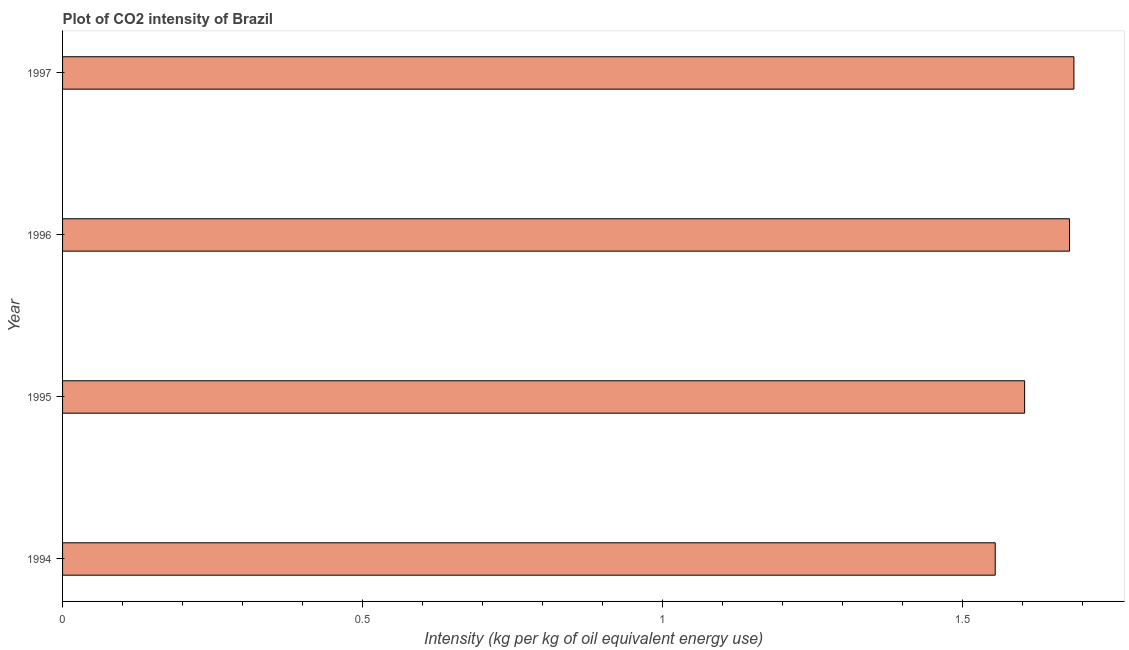Does the graph contain any zero values?
Ensure brevity in your answer.  No. What is the title of the graph?
Keep it short and to the point. Plot of CO2 intensity of Brazil. What is the label or title of the X-axis?
Your response must be concise. Intensity (kg per kg of oil equivalent energy use). What is the co2 intensity in 1996?
Your answer should be compact. 1.68. Across all years, what is the maximum co2 intensity?
Offer a very short reply. 1.69. Across all years, what is the minimum co2 intensity?
Your answer should be very brief. 1.55. In which year was the co2 intensity maximum?
Offer a very short reply. 1997. What is the sum of the co2 intensity?
Make the answer very short. 6.52. What is the difference between the co2 intensity in 1994 and 1997?
Ensure brevity in your answer.  -0.13. What is the average co2 intensity per year?
Keep it short and to the point. 1.63. What is the median co2 intensity?
Offer a very short reply. 1.64. Do a majority of the years between 1995 and 1997 (inclusive) have co2 intensity greater than 1.6 kg?
Keep it short and to the point. Yes. What is the ratio of the co2 intensity in 1994 to that in 1997?
Keep it short and to the point. 0.92. Is the difference between the co2 intensity in 1994 and 1997 greater than the difference between any two years?
Your response must be concise. Yes. What is the difference between the highest and the second highest co2 intensity?
Ensure brevity in your answer.  0.01. What is the difference between the highest and the lowest co2 intensity?
Your answer should be compact. 0.13. How many bars are there?
Provide a short and direct response. 4. Are all the bars in the graph horizontal?
Make the answer very short. Yes. How many years are there in the graph?
Make the answer very short. 4. What is the difference between two consecutive major ticks on the X-axis?
Provide a succinct answer. 0.5. What is the Intensity (kg per kg of oil equivalent energy use) of 1994?
Offer a terse response. 1.55. What is the Intensity (kg per kg of oil equivalent energy use) in 1995?
Give a very brief answer. 1.6. What is the Intensity (kg per kg of oil equivalent energy use) in 1996?
Your answer should be compact. 1.68. What is the Intensity (kg per kg of oil equivalent energy use) in 1997?
Offer a very short reply. 1.69. What is the difference between the Intensity (kg per kg of oil equivalent energy use) in 1994 and 1995?
Offer a terse response. -0.05. What is the difference between the Intensity (kg per kg of oil equivalent energy use) in 1994 and 1996?
Your response must be concise. -0.12. What is the difference between the Intensity (kg per kg of oil equivalent energy use) in 1994 and 1997?
Ensure brevity in your answer.  -0.13. What is the difference between the Intensity (kg per kg of oil equivalent energy use) in 1995 and 1996?
Give a very brief answer. -0.07. What is the difference between the Intensity (kg per kg of oil equivalent energy use) in 1995 and 1997?
Give a very brief answer. -0.08. What is the difference between the Intensity (kg per kg of oil equivalent energy use) in 1996 and 1997?
Offer a terse response. -0.01. What is the ratio of the Intensity (kg per kg of oil equivalent energy use) in 1994 to that in 1995?
Keep it short and to the point. 0.97. What is the ratio of the Intensity (kg per kg of oil equivalent energy use) in 1994 to that in 1996?
Provide a succinct answer. 0.93. What is the ratio of the Intensity (kg per kg of oil equivalent energy use) in 1994 to that in 1997?
Offer a very short reply. 0.92. What is the ratio of the Intensity (kg per kg of oil equivalent energy use) in 1995 to that in 1996?
Ensure brevity in your answer.  0.95. What is the ratio of the Intensity (kg per kg of oil equivalent energy use) in 1995 to that in 1997?
Ensure brevity in your answer.  0.95. What is the ratio of the Intensity (kg per kg of oil equivalent energy use) in 1996 to that in 1997?
Keep it short and to the point. 1. 